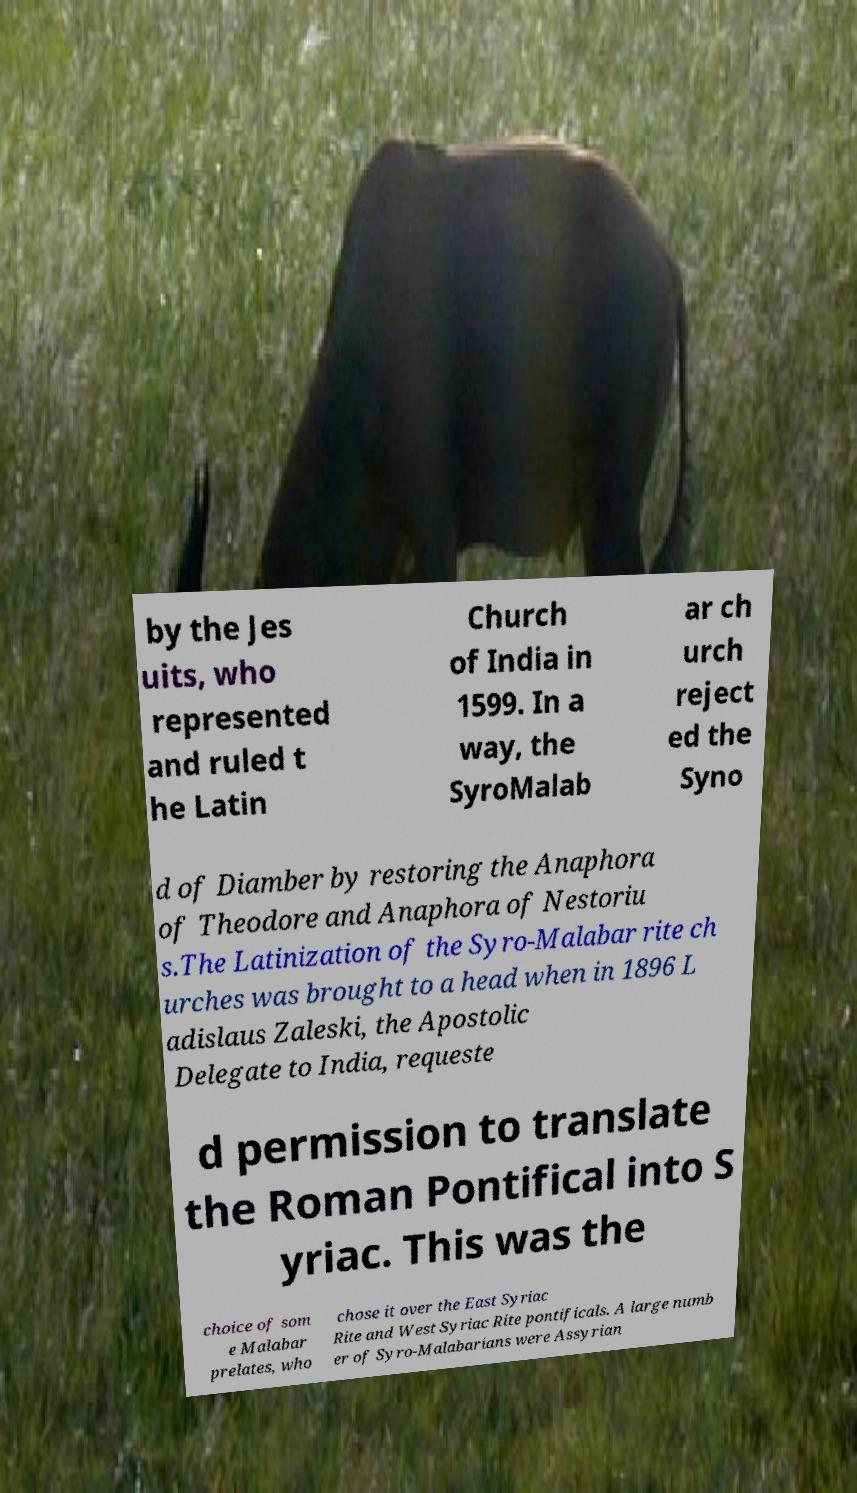I need the written content from this picture converted into text. Can you do that? by the Jes uits, who represented and ruled t he Latin Church of India in 1599. In a way, the SyroMalab ar ch urch reject ed the Syno d of Diamber by restoring the Anaphora of Theodore and Anaphora of Nestoriu s.The Latinization of the Syro-Malabar rite ch urches was brought to a head when in 1896 L adislaus Zaleski, the Apostolic Delegate to India, requeste d permission to translate the Roman Pontifical into S yriac. This was the choice of som e Malabar prelates, who chose it over the East Syriac Rite and West Syriac Rite pontificals. A large numb er of Syro-Malabarians were Assyrian 